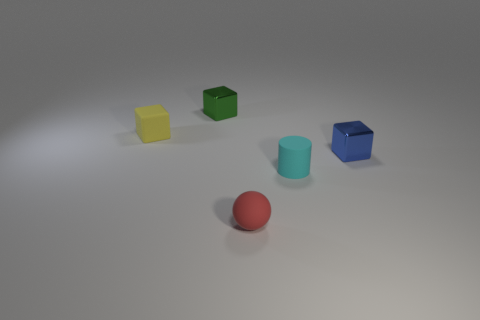What size is the yellow thing that is the same shape as the green object?
Make the answer very short. Small. How many blue metal things are in front of the metal block that is to the right of the cyan cylinder?
Your answer should be very brief. 0. Is the material of the block that is left of the small green cube the same as the tiny cylinder behind the tiny red rubber ball?
Ensure brevity in your answer.  Yes. How many other things are the same shape as the yellow thing?
Ensure brevity in your answer.  2. What number of matte cylinders have the same color as the small sphere?
Provide a succinct answer. 0. There is a tiny rubber object behind the small cyan cylinder; does it have the same shape as the tiny shiny thing that is on the right side of the green cube?
Offer a very short reply. Yes. How many small objects are left of the metallic thing behind the shiny object that is in front of the tiny yellow matte block?
Offer a terse response. 1. There is a small block that is on the right side of the tiny rubber thing on the right side of the red thing that is right of the yellow thing; what is it made of?
Make the answer very short. Metal. Are the tiny object that is behind the small matte block and the red ball made of the same material?
Offer a terse response. No. How many matte balls have the same size as the cylinder?
Keep it short and to the point. 1. 